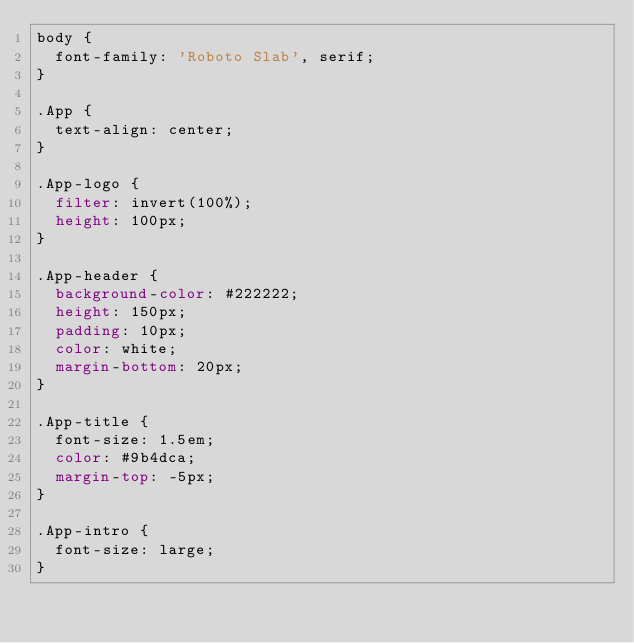Convert code to text. <code><loc_0><loc_0><loc_500><loc_500><_CSS_>body {
  font-family: 'Roboto Slab', serif;
}

.App {
  text-align: center;
}

.App-logo {
  filter: invert(100%);
  height: 100px;
}

.App-header {
  background-color: #222222;
  height: 150px;
  padding: 10px;
  color: white;
  margin-bottom: 20px;
}

.App-title {
  font-size: 1.5em;
  color: #9b4dca;
  margin-top: -5px;
}

.App-intro {
  font-size: large;
}
</code> 